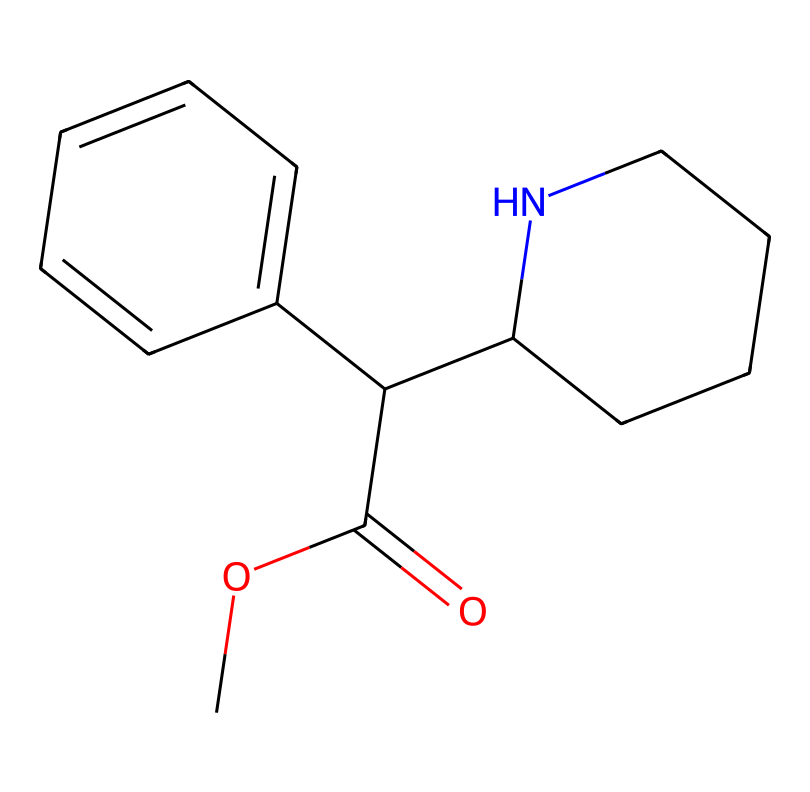What is the molecular formula of methylphenidate? By analyzing the SMILES representation and counting the atoms of each element present in the structure, we can derive the molecular formula. The breakdown includes 13 carbon (C), 19 hydrogen (H), 2 nitrogen (N), and 2 oxygen (O) atoms, resulting in the formula C13H19N2O2.
Answer: C13H19N2O2 How many rings are present in the chemical structure? The SMILES can be analyzed to identify ring structures. In this case, there are two rings in the structure, denoted by the presence of the 'C1' markers in the SMILES notation.
Answer: 2 What type of chemical is methylphenidate? Methylphenidate is classified as a stimulant drug, which can be inferred from its structural features and its pharmacological properties.
Answer: stimulant Which part of the molecule features nitrogen? Looking at the structure represented in the SMILES, nitrogen is present in the piperidine ring, indicated by the 'N' in the notation. This single 'N' suggests the nitrogen atom is integral to the structure's activity.
Answer: piperidine Does this chemical have a chiral center? A chiral center is determined by the presence of a carbon atom attached to four different substituents. Upon examining the structure, we find that there is indeed one such carbon atom, marking the molecule as chiral.
Answer: yes What functional groups are present in this molecule? By closely inspecting the SMILES representation, we can identify functional groups. Methylphenidate contains a carboxylic acid group (–COOH) and an ester linkage (–COC) as part of its structure.
Answer: carboxylic acid and ester 